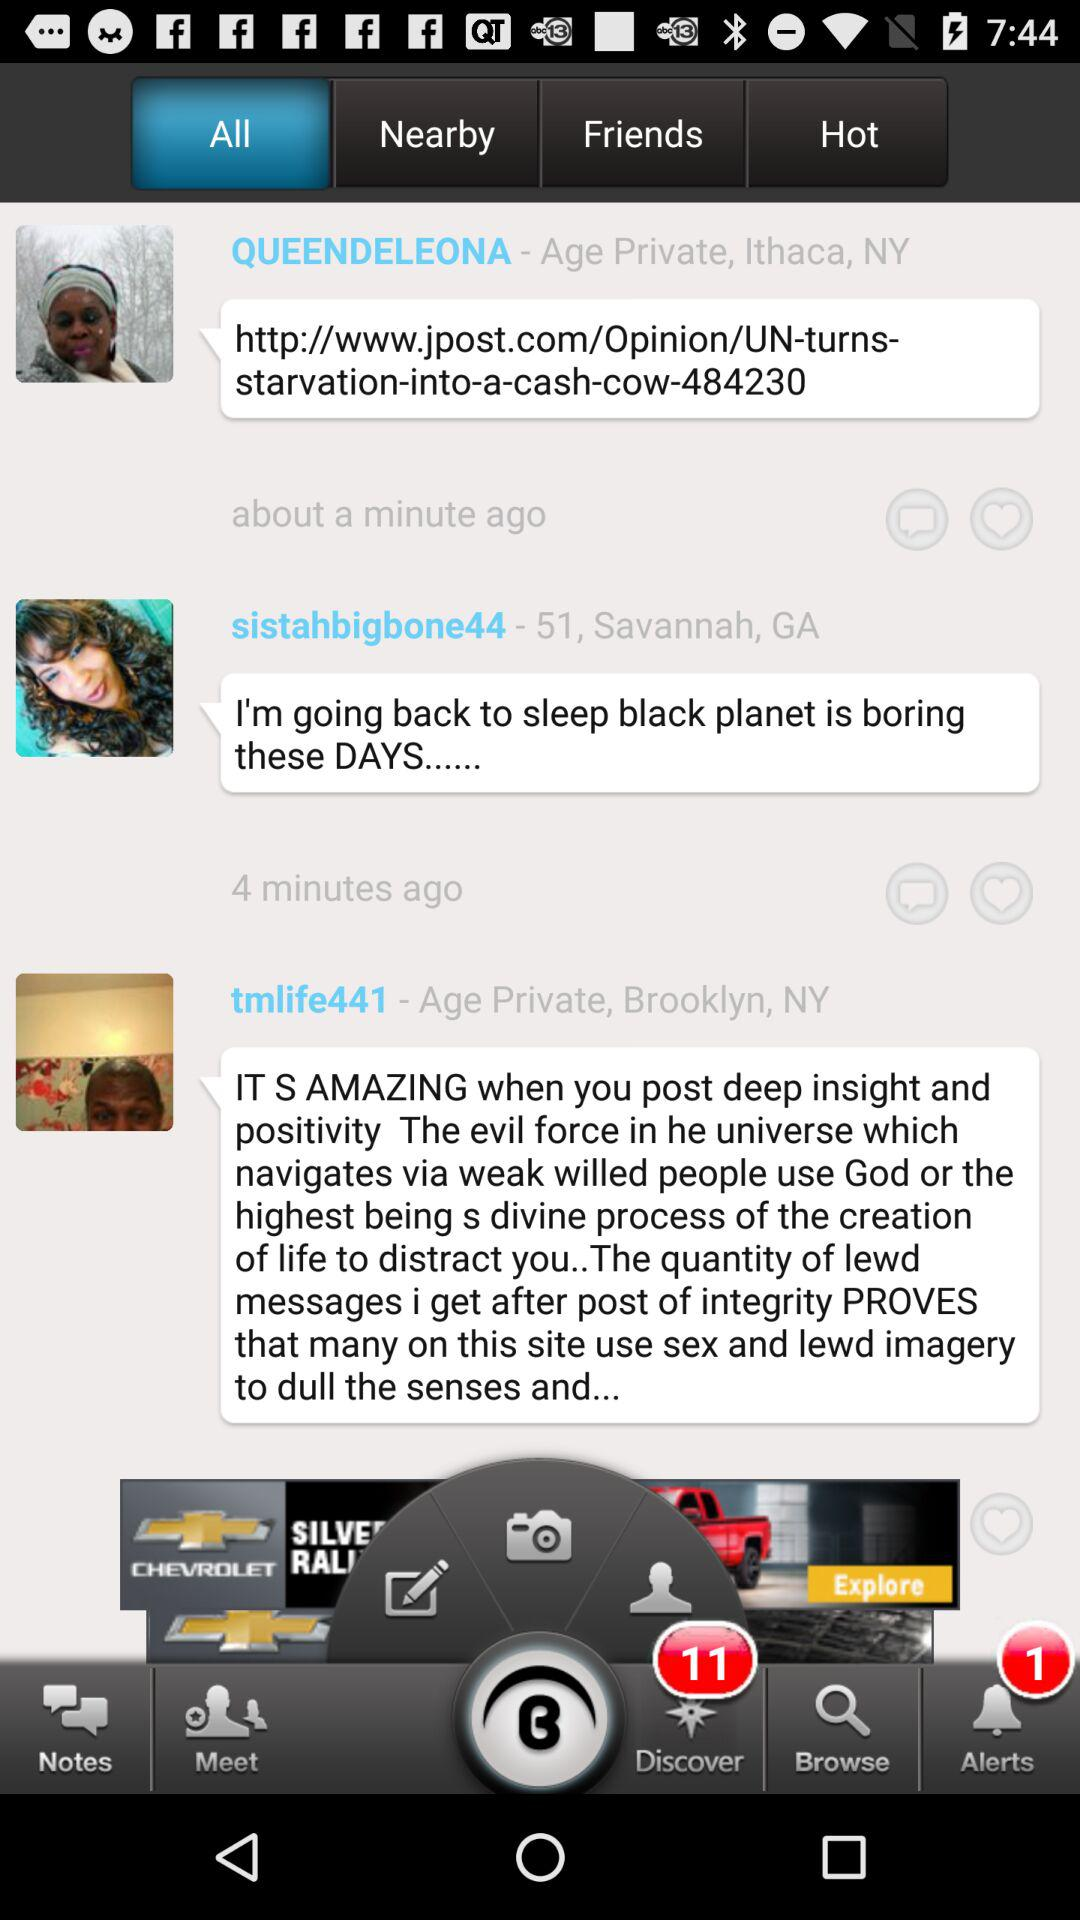What is the location of "tmlife441"? The location of "tmlife441" is Brooklyn, NY. 